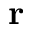<formula> <loc_0><loc_0><loc_500><loc_500>\mathbf r</formula> 